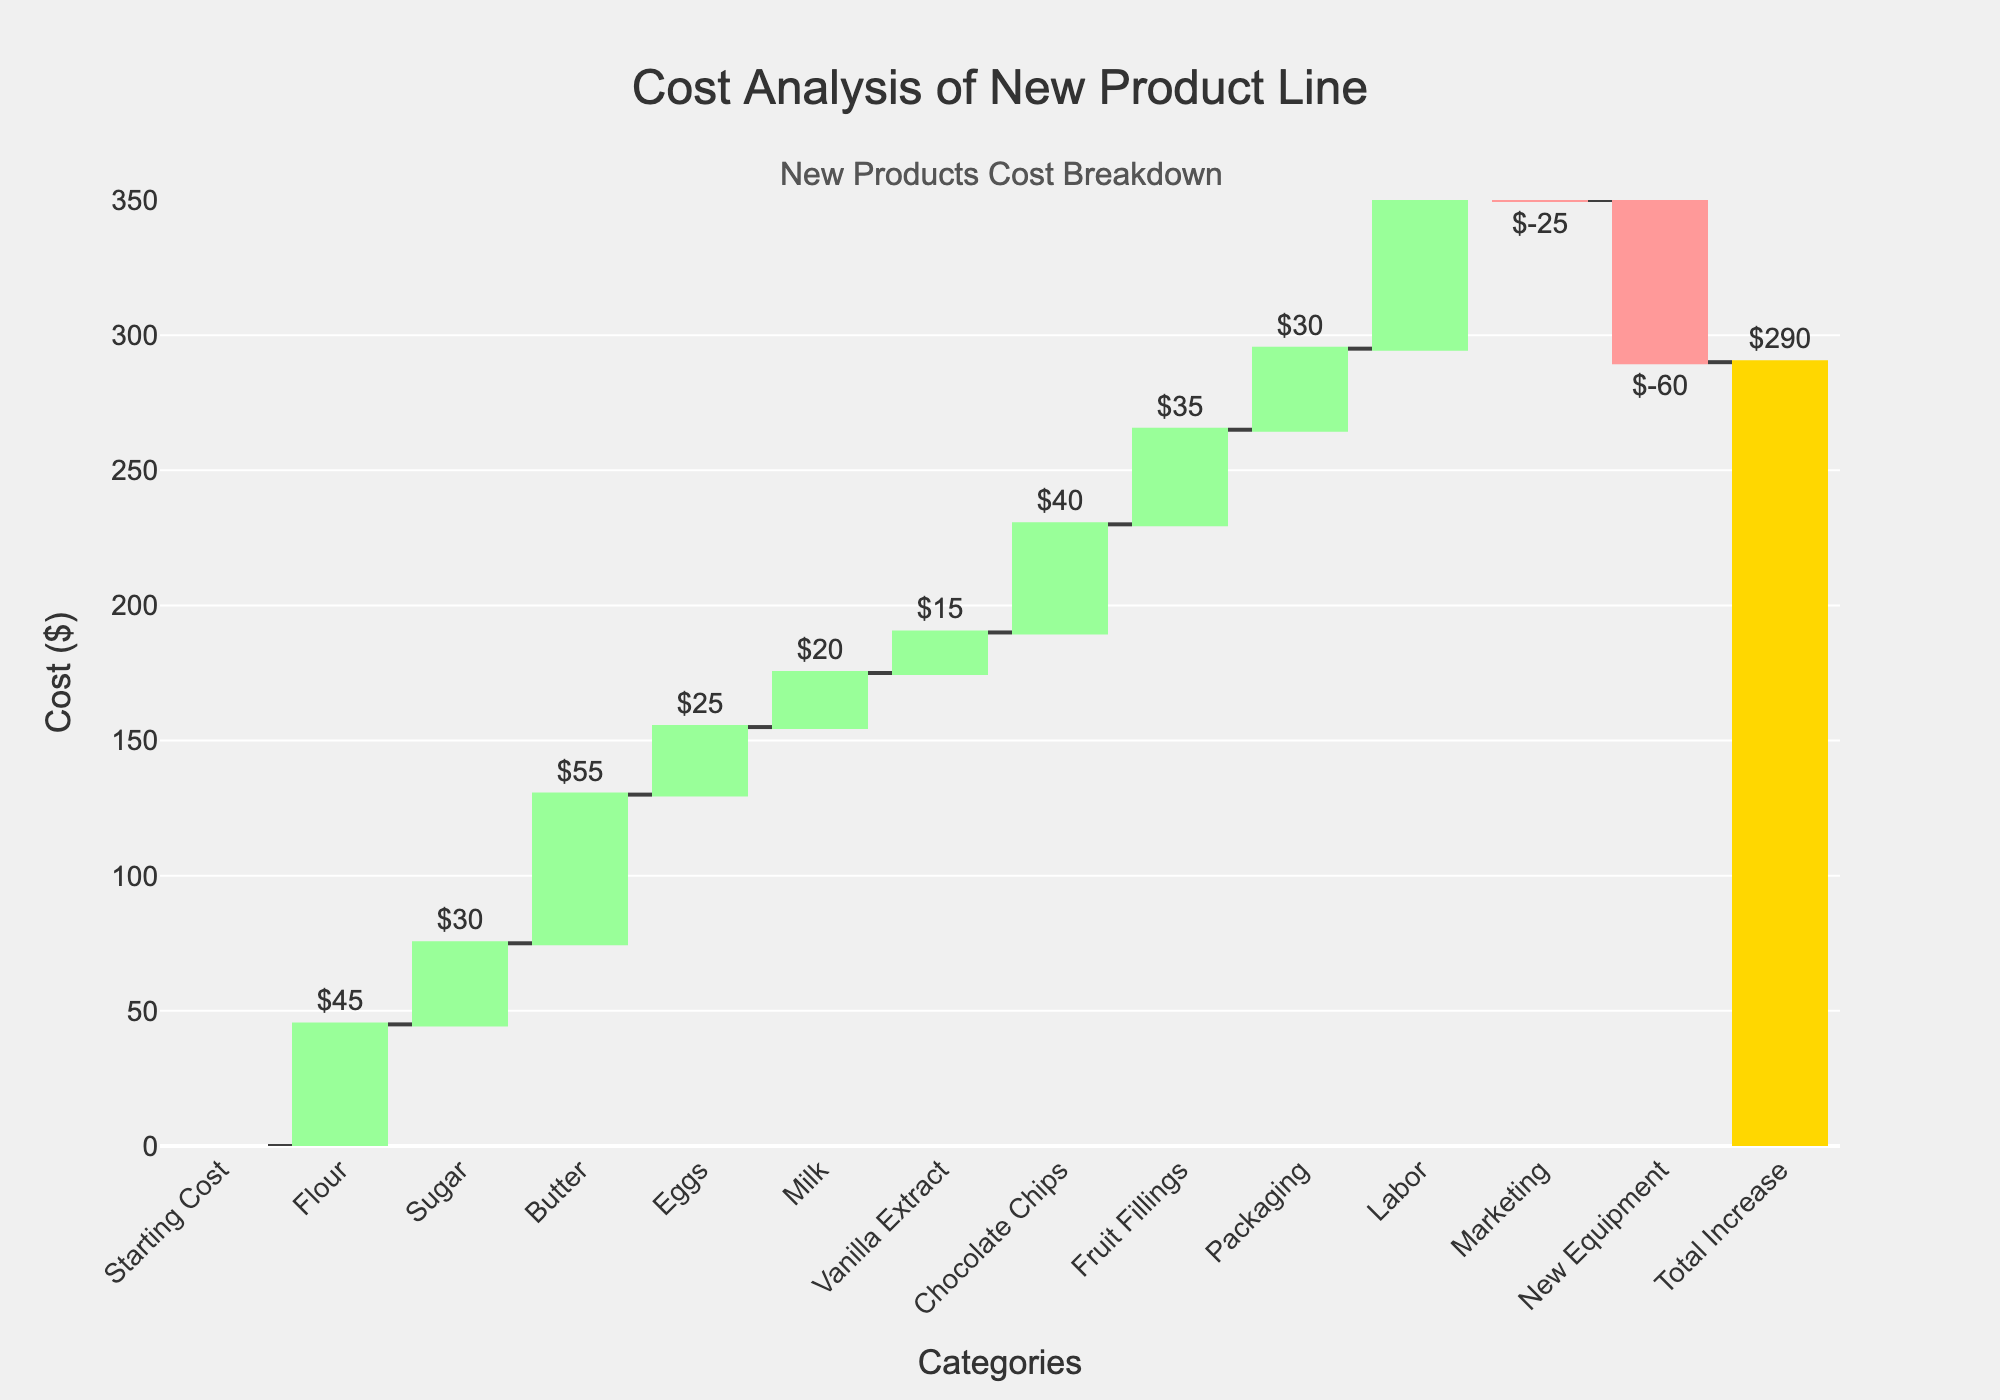What is the title of the waterfall chart? The title of a chart is typically displayed prominently at the top of the figure. Here, the title is given as "Cost Analysis of New Product Line."
Answer: Cost Analysis of New Product Line What is the final total cost increase shown in the chart? The final total typically appears at the end of the waterfall steps. In this chart, the "Total Increase" is highlighted and the text displays "$290."
Answer: $290 Which ingredient contributes the highest cost to the new product line? Each bar represents a different cost category, and by judging the height of the bars, "Labor" has the highest value among all ingredients and costs listed, with $80.
Answer: Labor What is the cumulative cost of Flour, Sugar, and Butter? Add the individual costs of Flour ($45), Sugar ($30), and Butter ($55). The calculation is: 45 + 30 + 55 = 130.
Answer: 130 How does the marketing cost impact the overall total? The marketing cost is indicated with a negative value (-$25) which represents a reduction in cost. Subtracting $25 reduces the overall expenses by $25.
Answer: It decreases the overall cost by $25 Which expense categories contribute negatively to the overall cost? Looking for negative bars or values on the chart, "Marketing" (-$25) and "New Equipment" (-$60) are the categories that contribute negatively.
Answer: Marketing and New Equipment By how much is the cost of Chocolate Chips greater than the cost of Vanilla Extract? Subtract the cost of Vanilla Extract ($15) from the cost of Chocolate Chips ($40). The calculation is: 40 - 15 = 25.
Answer: $25 What are the two smallest cost categories after Starting Cost and how much do they add up to? Analyzing the heights of the bars, the two smallest positive cost categories are Milk ($20) and Vanilla Extract ($15). Their combined cost is: 20 + 15 = 35.
Answer: Milk and Vanilla Extract; $35 Is the expense of Fruit Fillings greater than that of Butter? Compare the bars for Fruit Fillings ($35) and Butter ($55). Butter has a higher value than Fruit Fillings.
Answer: No Which ingredient has the closest cost to $30? The bar labeled "Sugar" is marked with $30, which is exactly $30.
Answer: Sugar 